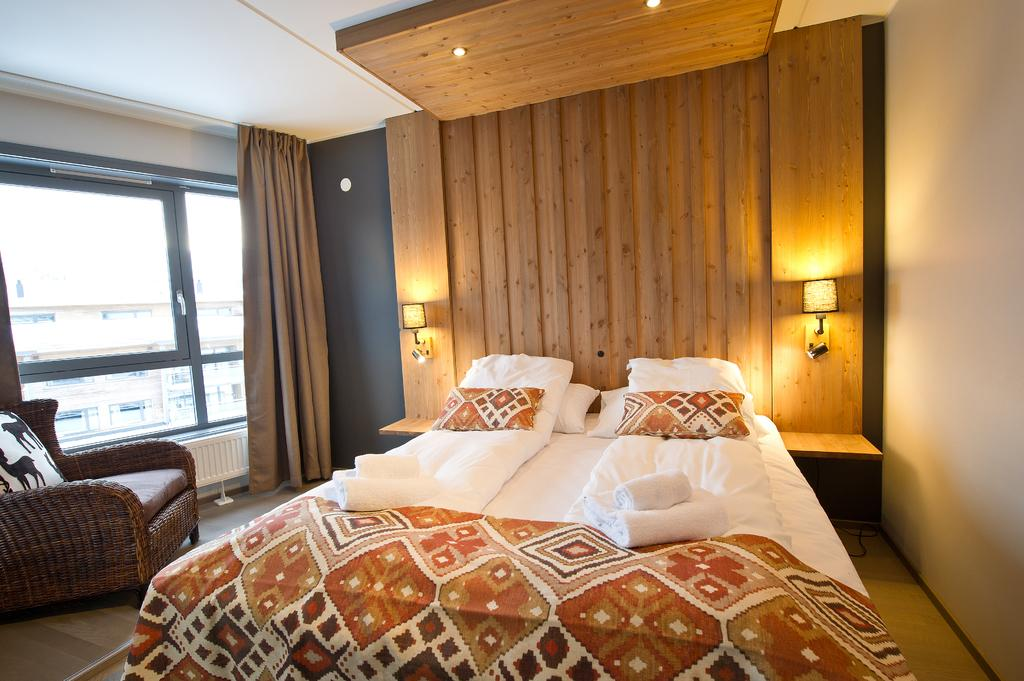What piece of furniture is present in the image? There is a bed in the image. What accessories are on the bed? There are pillows, blankets, and a mattress on the bed. What type of lighting is present in the image? There are lamps in the image. What is the background of the image? There is a wooden wall in the background. Is there any window treatment present in the image? Yes, there is a curtain associated with the window. Can you describe the window in the image? There is a window in the background. What type of cherry is being used as a decoration on the bed? There is no cherry present in the image, as it is a bed with pillows, blankets, and a mattress. 